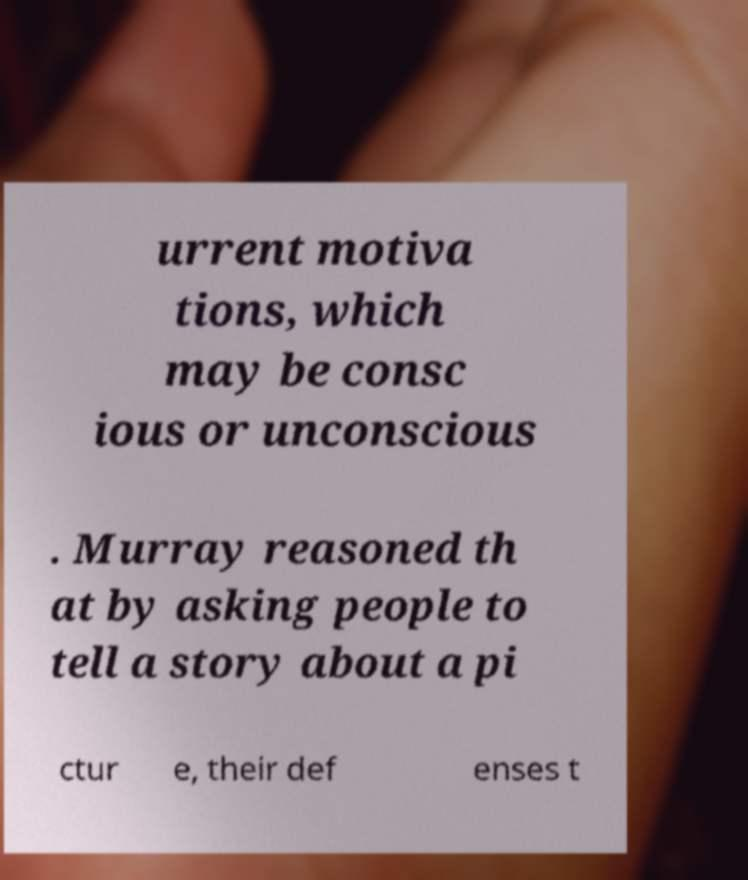Please read and relay the text visible in this image. What does it say? urrent motiva tions, which may be consc ious or unconscious . Murray reasoned th at by asking people to tell a story about a pi ctur e, their def enses t 